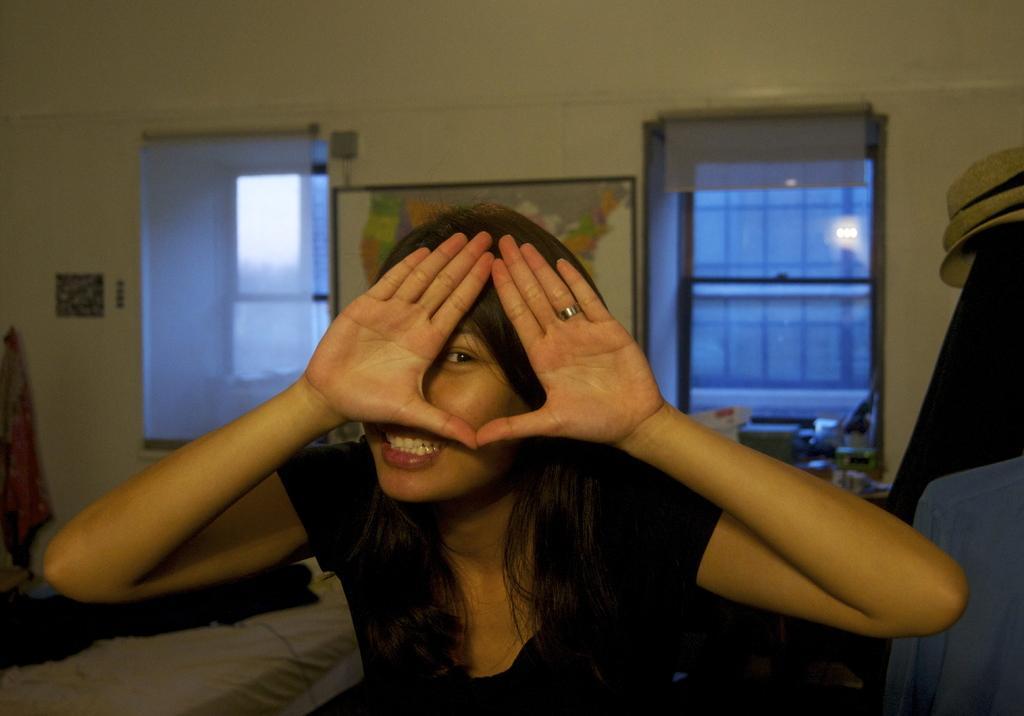Can you describe this image briefly? In the image we can see a woman wearing clothes, finger ring and she is smiling. Behind her we can see there are two windows and frame, stick to the wall. 